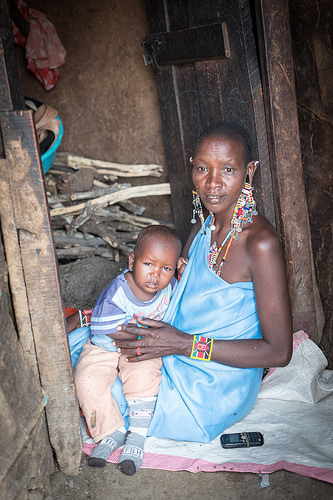<image>
Is there a mother to the left of the child? No. The mother is not to the left of the child. From this viewpoint, they have a different horizontal relationship. 